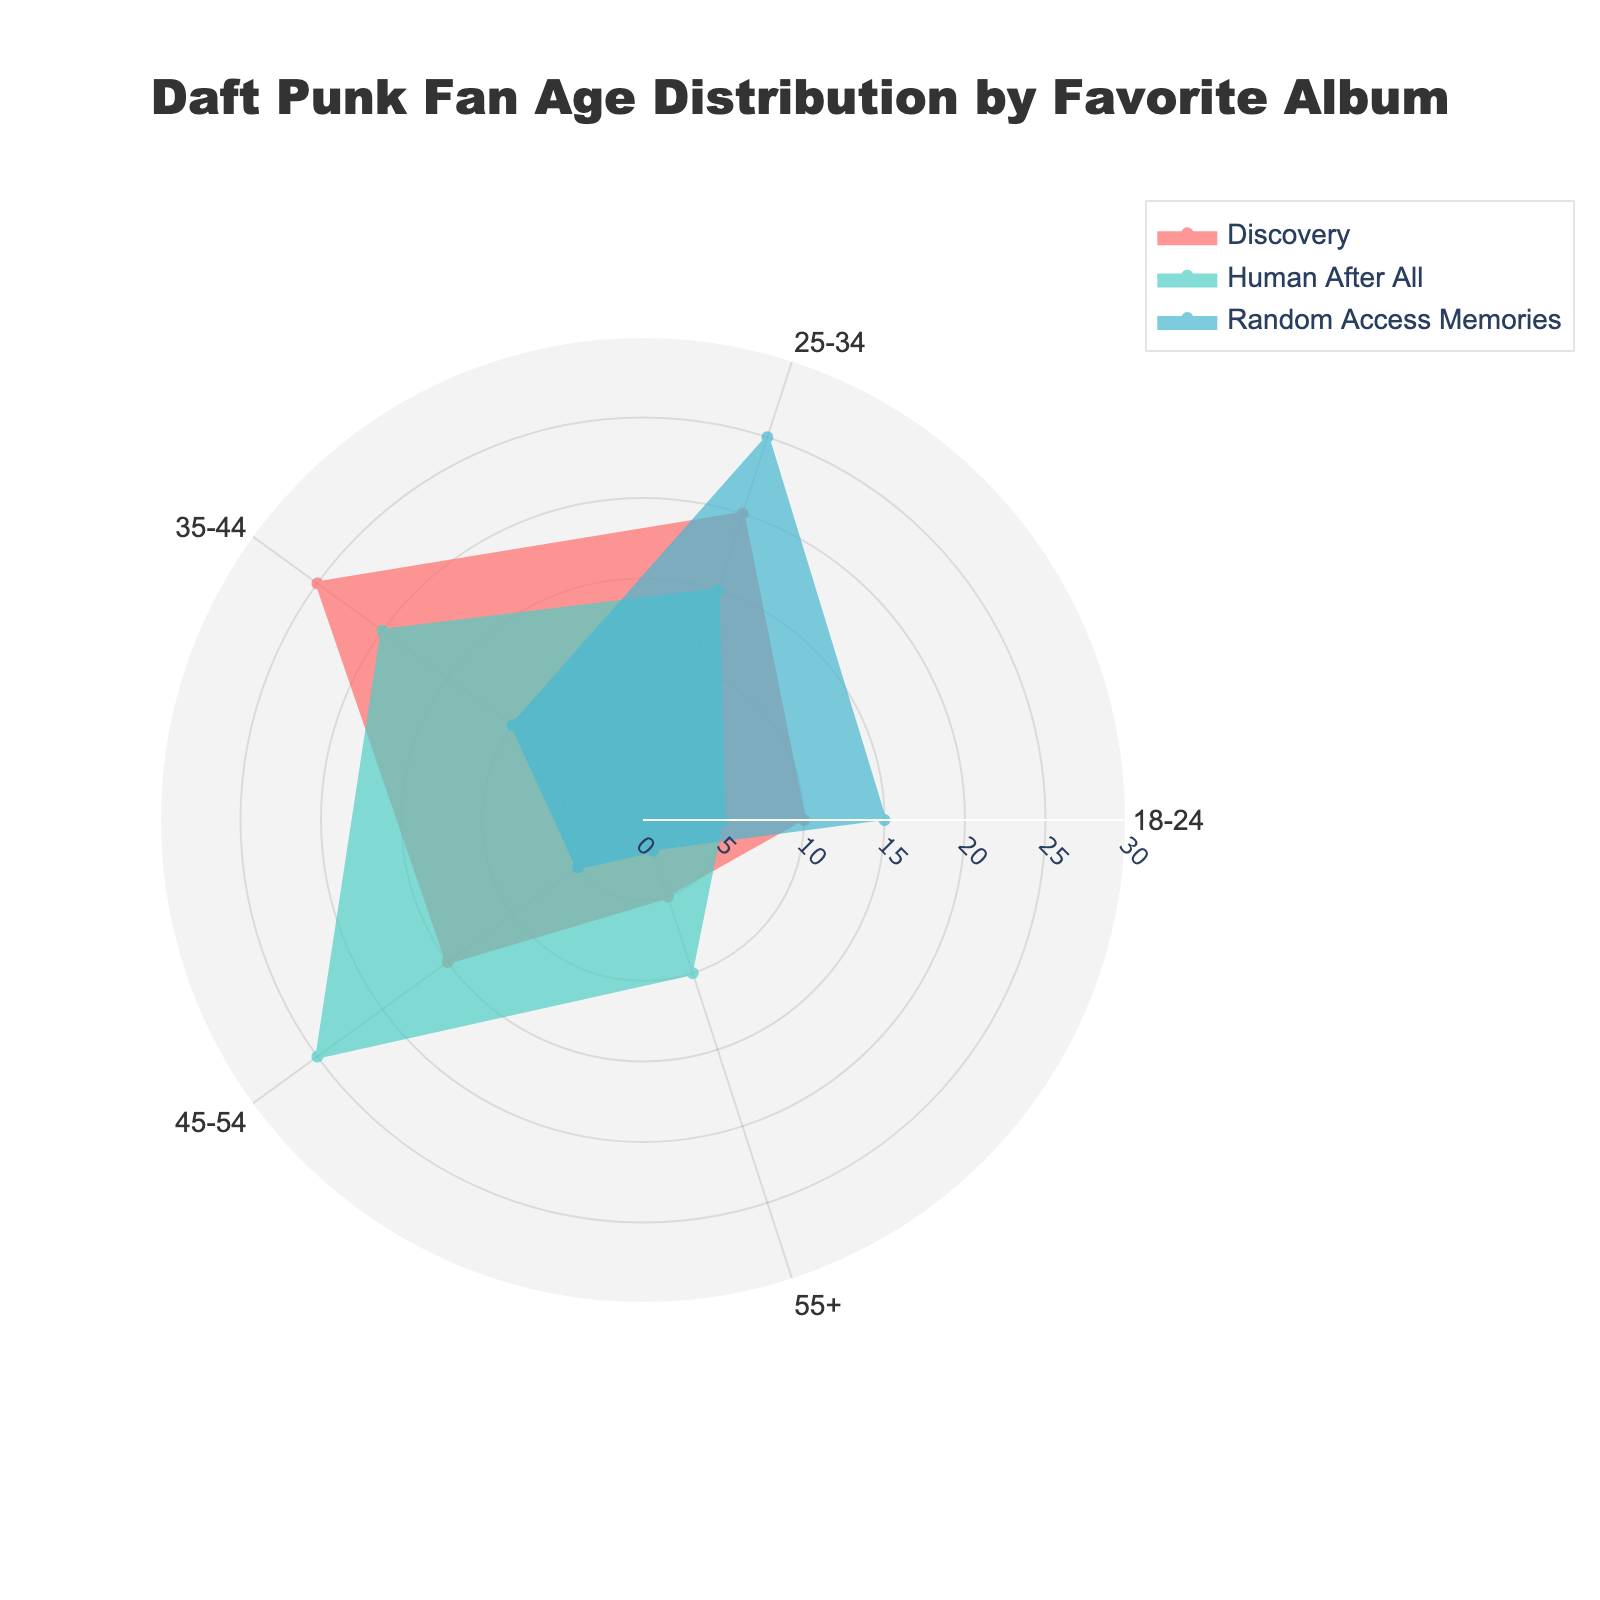What is the highest value for 'Discovery' across all age groups? Looking at the radar (polar area) chart, we see that each age group has a segment for the album 'Discovery'. The highest value for the album 'Discovery' is in the 35-44 age group, which is 25.
Answer: 25 Which age group prefers 'Random Access Memories' the most? By examining the chart, 'Random Access Memories' is represented by a specific color. Observing the length of the corresponding segments for each age group, the 25-34 age group has the longest segment with a value of 25.
Answer: 25-34 How many age groups have a higher preference for 'Human After All' than 'Discovery'? Compare the segments for both 'Human After All' and 'Discovery' across all age groups. We see that the age groups 45-54 and 55+ have higher values for 'Human After All' compared to 'Discovery'.
Answer: 2 Which age group has the smallest difference in preference between 'Human After All' and 'Random Access Memories'? Calculate the absolute difference in values between 'Human After All' and 'Random Access Memories' for each age group. The smallest difference is found in the 35-44 age group, which is
Answer: 35-44 What is the difference in preference for 'Discovery' between the 18-24 and 35-44 age groups? From the chart, the preference for 'Discovery' in the 18-24 age group is 10, and for the 35-44 age group, it's 25. The difference is 25 - 10 = 15.
Answer: 15 Which album has the highest preference in the 45-54 age group? Observing the chart, 'Human After All' has the longest segment for the 45-54 age group with a value of 25.
Answer: Human After All What is the total preference count for 'Discovery' across all age groups? Sum the values of 'Discovery' across each age group's segment: 10 (18-24) + 20 (25-34) + 25 (35-44) + 15 (45-54) + 5 (55+). The total is 75.
Answer: 75 Between 'Human After All' and 'Random Access Memories', which album has a more consistent preference (less variability) across different age groups? Assess the segments representing 'Human After All' and 'Random Access Memories'. 'Human After All' has values like 5, 15, 20, 25, 10, and 'Random Access Memories' has 15, 25, 10, 5, 2. There is less variability in 'Human After All' preferences.
Answer: Human After All Which age group is least interested in 'Random Access Memories'? The smallest segment for 'Random Access Memories' is in the 55+ age group with a value of 2.
Answer: 55+ What is the overall trend in preference for 'Human After All' as age increases? Observing the chart, the preferences for 'Human After All' generally increase from younger to middle-aged groups, peaking at 45-54, then slightly decrease for 55+.
Answer: Increases then slightly decreases 